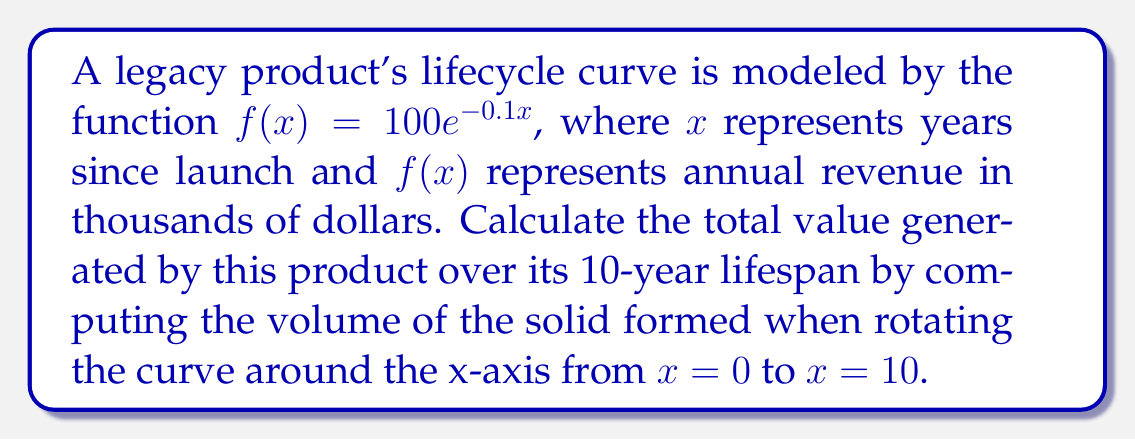Can you answer this question? To solve this problem, we'll use the washer method for calculating the volume of a solid of revolution:

1) The formula for the volume is:
   $$V = \pi \int_a^b [f(x)]^2 dx$$

2) We're given:
   $f(x) = 100e^{-0.1x}$
   $a = 0$, $b = 10$

3) Substituting into the formula:
   $$V = \pi \int_0^{10} (100e^{-0.1x})^2 dx$$

4) Simplify the integrand:
   $$V = \pi \int_0^{10} 10000e^{-0.2x} dx$$

5) Integrate:
   $$V = \pi \cdot 10000 \cdot [-5000e^{-0.2x}]_0^{10}$$

6) Evaluate the integral:
   $$V = \pi \cdot 10000 \cdot (-5000e^{-2} + 5000)$$

7) Calculate:
   $$V \approx 1,376,746.15$$

8) Since $f(x)$ was in thousands of dollars, multiply by 1000:
   $$V \approx 1,376,746,150$$

The volume represents the total value in dollars over the 10-year lifespan.
Answer: $1,376,746,150 